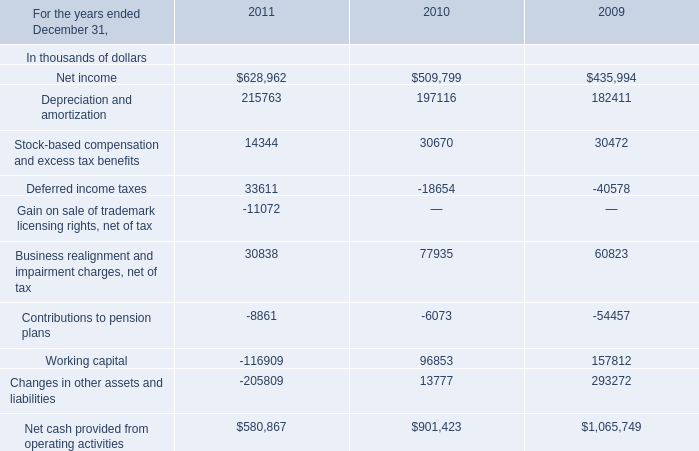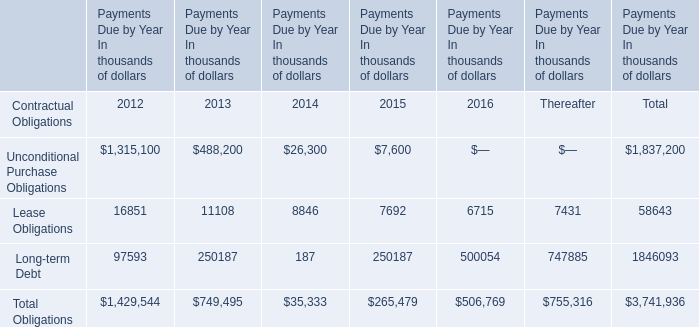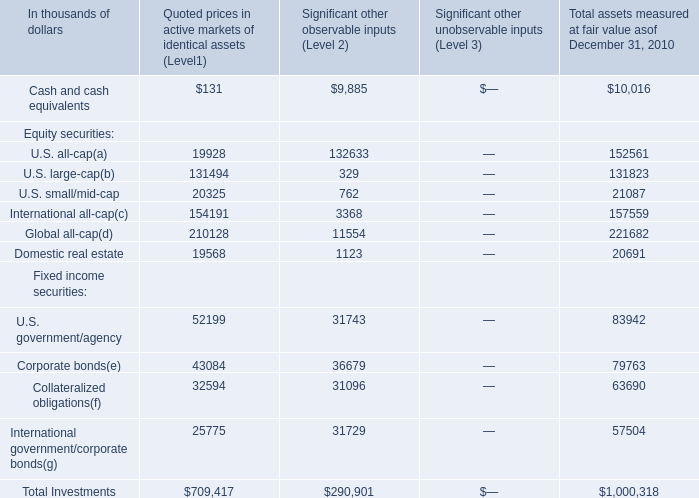What's the average of Fixed income securities in Total assets measured at fair value as of December 31, 2010? (in thousand) 
Computations: ((((83942 + 79763) + 63690) + 57504) / 4)
Answer: 71224.75. 